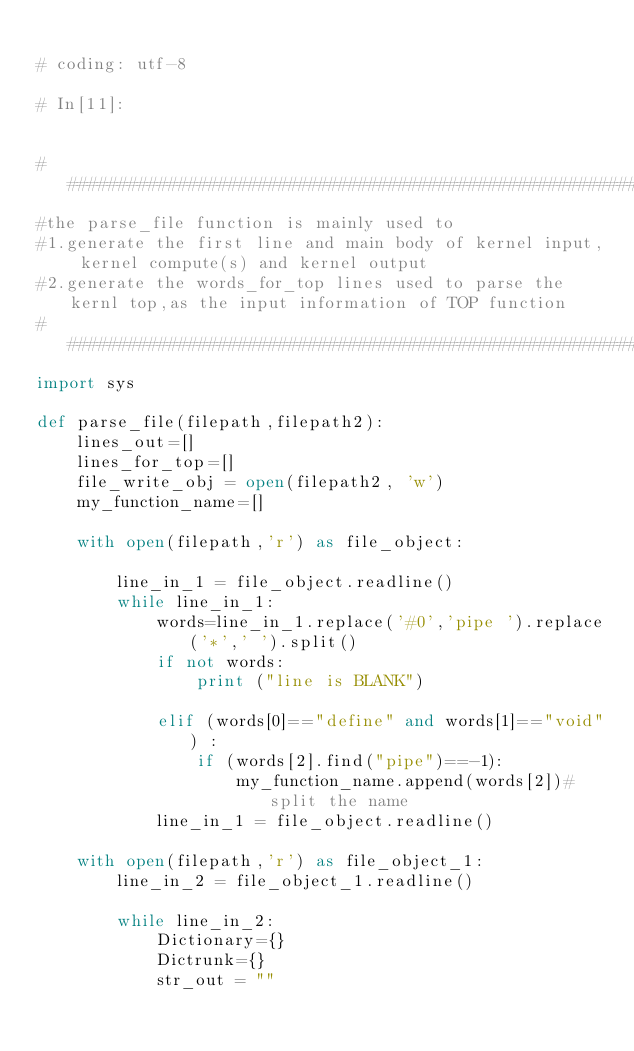<code> <loc_0><loc_0><loc_500><loc_500><_Python_>
# coding: utf-8

# In[11]:


################################################################################################## 
#the parse_file function is mainly used to 
#1.generate the first line and main body of kernel input, kernel compute(s) and kernel output
#2.generate the words_for_top lines used to parse the kernl top,as the input information of TOP function
##################################################################################################
import sys

def parse_file(filepath,filepath2):
    lines_out=[]
    lines_for_top=[] 
    file_write_obj = open(filepath2, 'w')
    my_function_name=[]
    
    with open(filepath,'r') as file_object:
        
        line_in_1 = file_object.readline()       
        while line_in_1:            
            words=line_in_1.replace('#0','pipe ').replace('*',' ').split()
            if not words:
                print ("line is BLANK")
           
            elif (words[0]=="define" and words[1]=="void") :
                if (words[2].find("pipe")==-1):
                    my_function_name.append(words[2])#split the name
            line_in_1 = file_object.readline()
            
    with open(filepath,'r') as file_object_1:
        line_in_2 = file_object_1.readline()
        
        while line_in_2:
            Dictionary={}
            Dictrunk={}
            str_out = ""</code> 